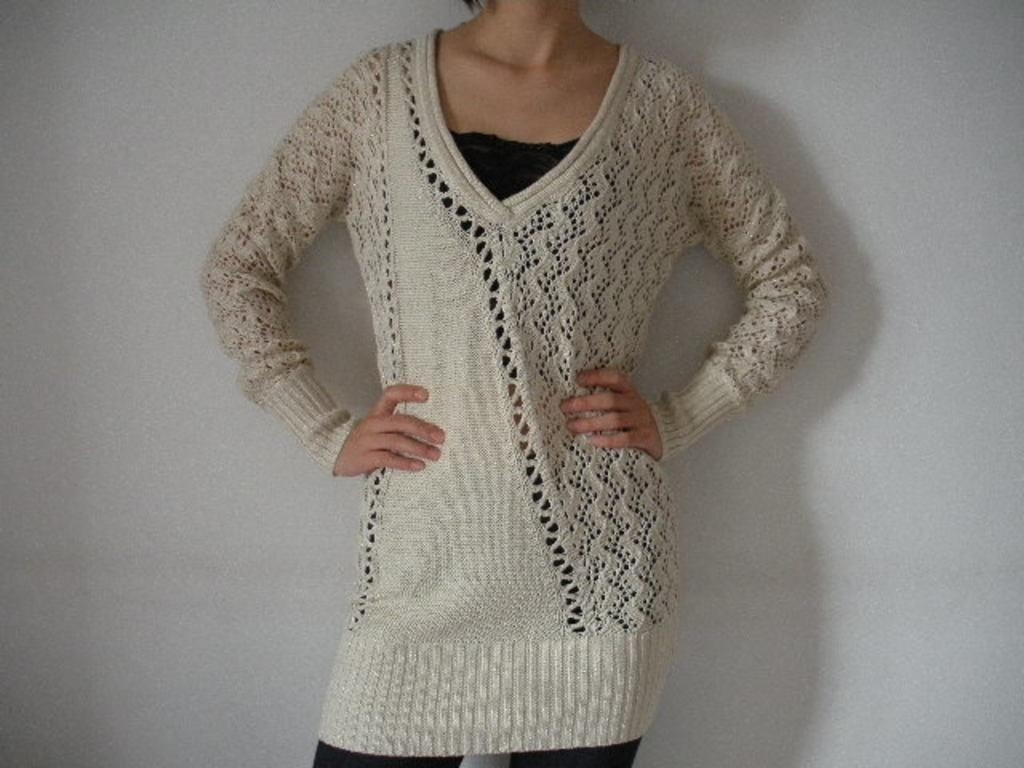Who or what is in the image? There is a person in the image. What is the person wearing? The person is wearing a white woolen top. What is the person's posture in the image? The person is standing. What can be seen in the background of the image? There is a wall visible in the background of the image. What type of bells can be heard ringing in the image? There are no bells present in the image, and therefore no sound can be heard. What is the person's interest in the image? The provided facts do not mention the person's interests, so we cannot determine their interest from the image. 